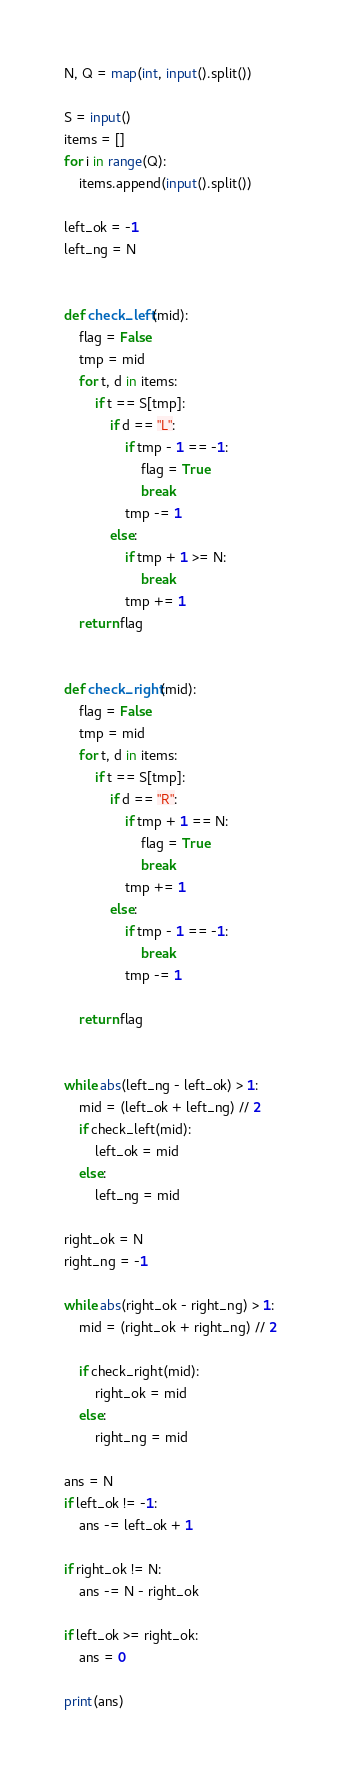<code> <loc_0><loc_0><loc_500><loc_500><_Python_>N, Q = map(int, input().split())

S = input()
items = []
for i in range(Q):
    items.append(input().split())

left_ok = -1
left_ng = N


def check_left(mid):
    flag = False
    tmp = mid
    for t, d in items:
        if t == S[tmp]:
            if d == "L":
                if tmp - 1 == -1:
                    flag = True
                    break
                tmp -= 1
            else:
                if tmp + 1 >= N:
                    break
                tmp += 1
    return flag


def check_right(mid):
    flag = False
    tmp = mid
    for t, d in items:
        if t == S[tmp]:
            if d == "R":
                if tmp + 1 == N:
                    flag = True
                    break
                tmp += 1
            else:
                if tmp - 1 == -1:
                    break
                tmp -= 1

    return flag


while abs(left_ng - left_ok) > 1:
    mid = (left_ok + left_ng) // 2
    if check_left(mid):
        left_ok = mid
    else:
        left_ng = mid

right_ok = N
right_ng = -1

while abs(right_ok - right_ng) > 1:
    mid = (right_ok + right_ng) // 2

    if check_right(mid):
        right_ok = mid
    else:
        right_ng = mid

ans = N
if left_ok != -1:
    ans -= left_ok + 1

if right_ok != N:
    ans -= N - right_ok

if left_ok >= right_ok:
    ans = 0

print(ans)
</code> 